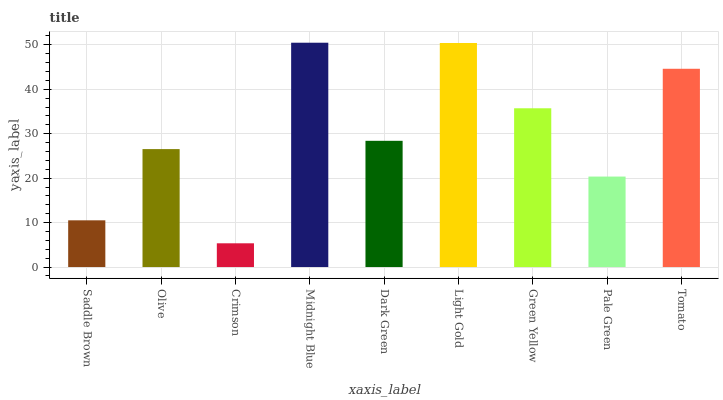Is Olive the minimum?
Answer yes or no. No. Is Olive the maximum?
Answer yes or no. No. Is Olive greater than Saddle Brown?
Answer yes or no. Yes. Is Saddle Brown less than Olive?
Answer yes or no. Yes. Is Saddle Brown greater than Olive?
Answer yes or no. No. Is Olive less than Saddle Brown?
Answer yes or no. No. Is Dark Green the high median?
Answer yes or no. Yes. Is Dark Green the low median?
Answer yes or no. Yes. Is Green Yellow the high median?
Answer yes or no. No. Is Saddle Brown the low median?
Answer yes or no. No. 